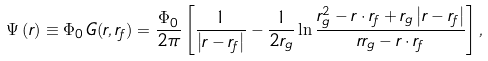<formula> <loc_0><loc_0><loc_500><loc_500>\Psi \left ( { r } \right ) \equiv \Phi _ { 0 } \, G ( { r } , { r _ { f } } ) = \frac { \Phi _ { 0 } } { 2 \pi } \left [ \frac { 1 } { \left | { r } - { r _ { f } } \right | } - \frac { 1 } { 2 r _ { g } } \ln \frac { r _ { g } ^ { 2 } - { r } \cdot { r _ { f } } + r _ { g } \left | { r } - { r _ { f } } \right | } { r r _ { g } - { r } \cdot { r _ { f } } } \right ] ,</formula> 